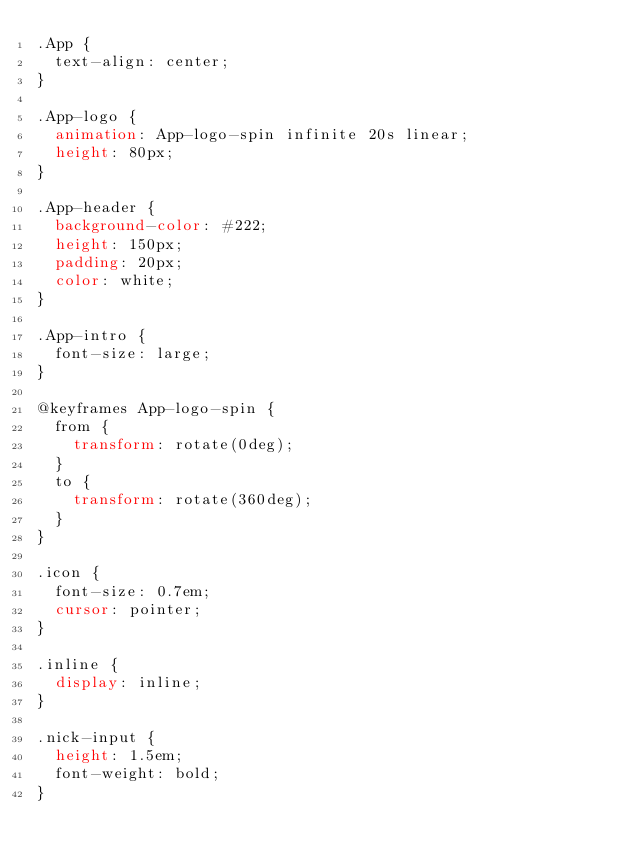Convert code to text. <code><loc_0><loc_0><loc_500><loc_500><_CSS_>.App {
  text-align: center;
}

.App-logo {
  animation: App-logo-spin infinite 20s linear;
  height: 80px;
}

.App-header {
  background-color: #222;
  height: 150px;
  padding: 20px;
  color: white;
}

.App-intro {
  font-size: large;
}

@keyframes App-logo-spin {
  from {
    transform: rotate(0deg);
  }
  to {
    transform: rotate(360deg);
  }
}

.icon {
  font-size: 0.7em;
  cursor: pointer;
}

.inline {
  display: inline;
}

.nick-input {
  height: 1.5em;
  font-weight: bold;
}
</code> 